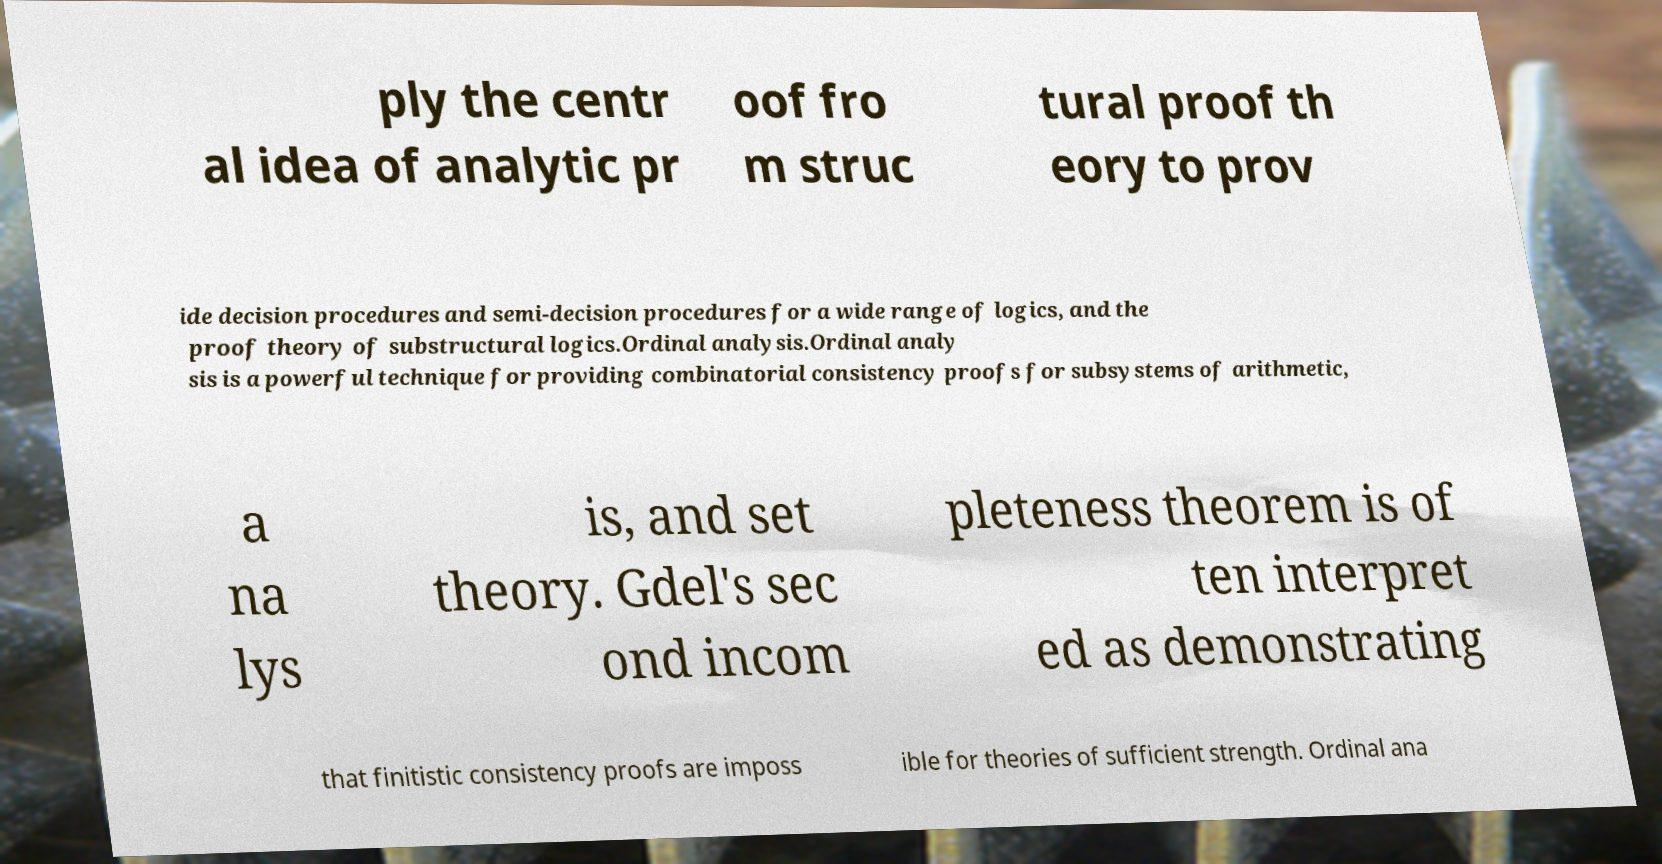There's text embedded in this image that I need extracted. Can you transcribe it verbatim? ply the centr al idea of analytic pr oof fro m struc tural proof th eory to prov ide decision procedures and semi-decision procedures for a wide range of logics, and the proof theory of substructural logics.Ordinal analysis.Ordinal analy sis is a powerful technique for providing combinatorial consistency proofs for subsystems of arithmetic, a na lys is, and set theory. Gdel's sec ond incom pleteness theorem is of ten interpret ed as demonstrating that finitistic consistency proofs are imposs ible for theories of sufficient strength. Ordinal ana 